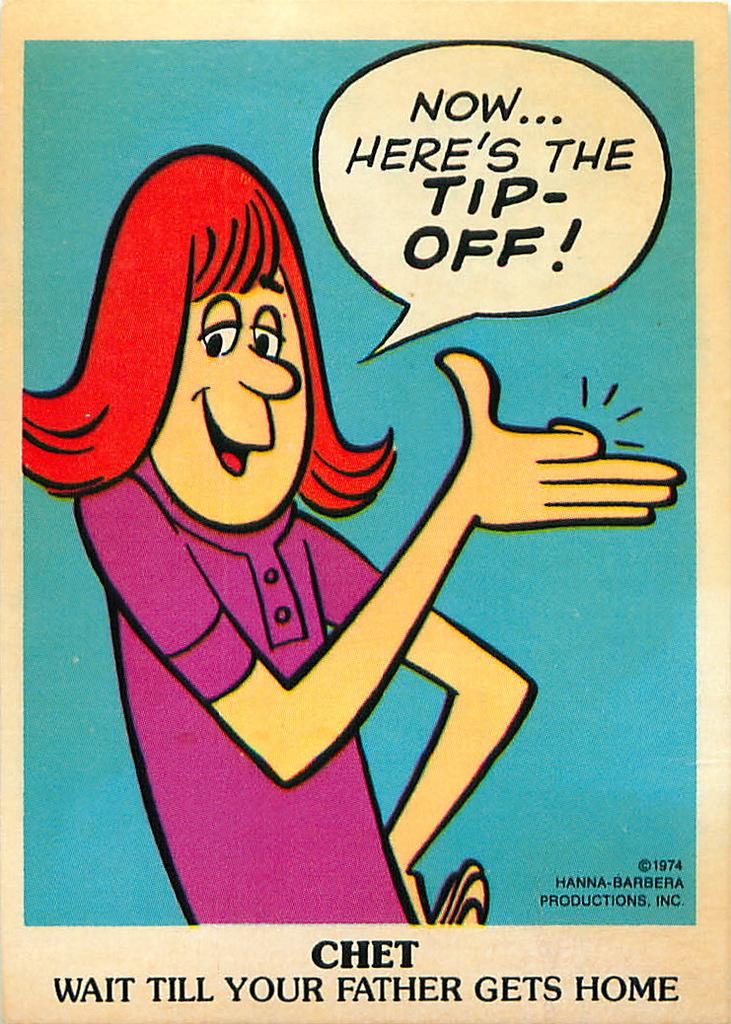<image>
Create a compact narrative representing the image presented. A comic cell that says "Now here's the tip off." 